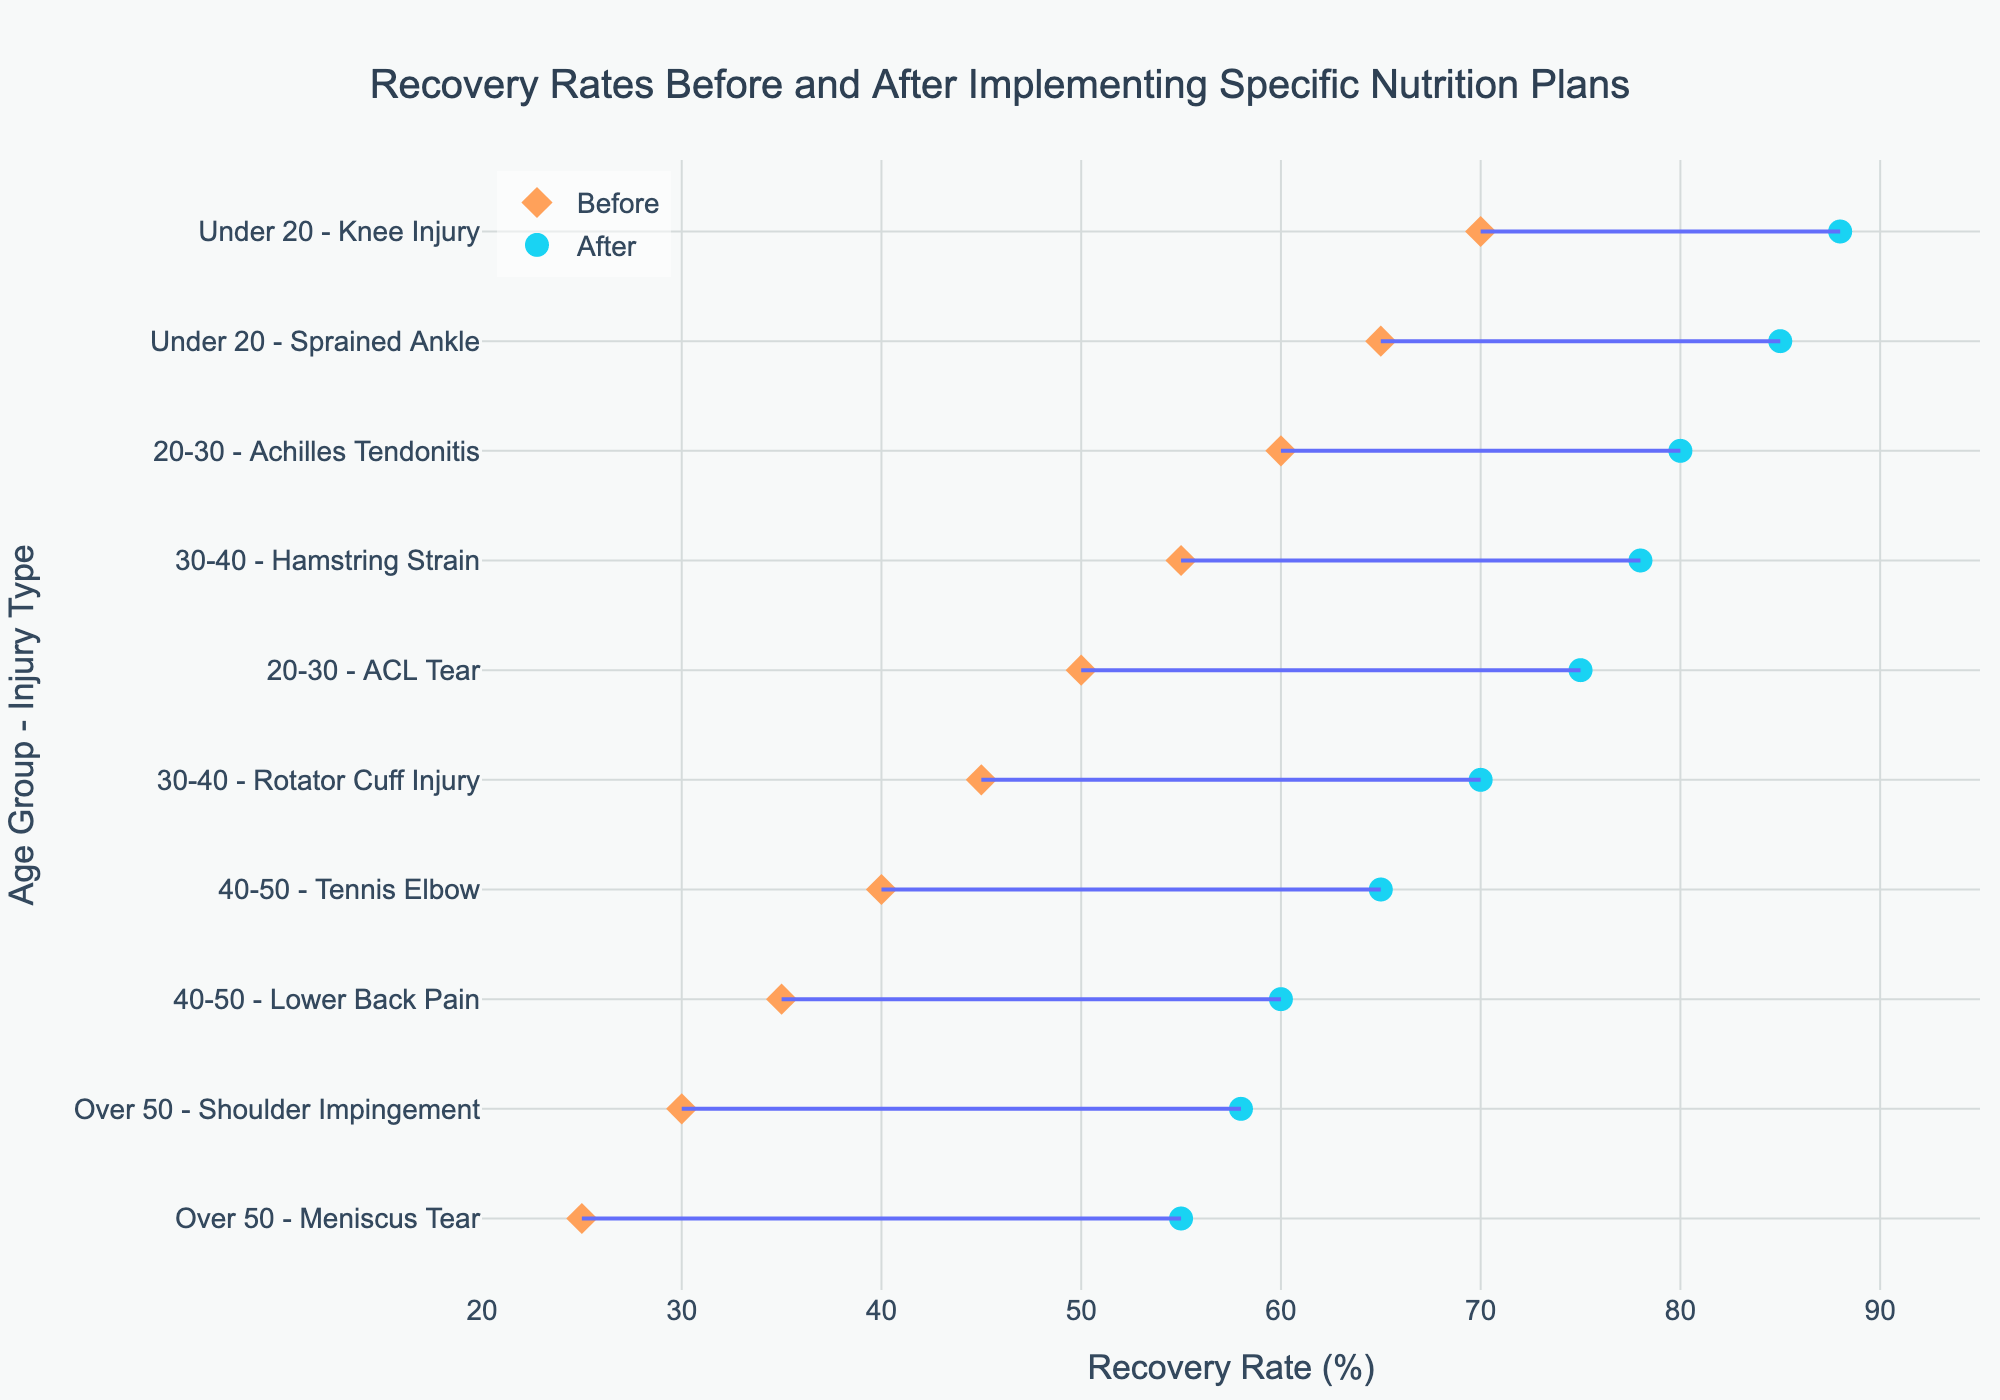What's the title of the plot? The title is typically located at the top of the plot. In this case, it states "Recovery Rates Before and After Implementing Specific Nutrition Plans".
Answer: Recovery Rates Before and After Implementing Specific Nutrition Plans What's the range of recovery rates on the x-axis? By examining the x-axis, we can see the minimum and maximum values provided. The range starts at 20 and goes up to 95.
Answer: 20 to 95 What colors are used to represent the recovery rates before and after implementing the specific nutrition plans? The colors of the markers indicate the two different states: the 'Before' rates are represented by an orange color and the 'After' rates by a light blue color.
Answer: Orange and Light Blue Which age group and injury type had the highest increase in recovery rate after implementing the nutrition plan? By comparing the lines, we can identify the largest vertical distance between the 'Before' and 'After' markers. The Under 20 age group with a Knee Injury shows an increase from 70% to 88%, a difference of 18%.
Answer: Under 20 - Knee Injury How many different nutrition plans are evaluated in the plot? By counting the distinct plans mentioned in the hovertext of the markers, we find there are five distinct nutrition plans (Omega-3 Enhanced Diet, High-Protein Diet, Antioxidant-Rich Diet, Anti-Inflammatory Diet, Calcium and Vitamin D-Rich Diet).
Answer: 5 For the age group Over 50, which injury type had the lowest recovery rate before implementing the nutrition plan? Looking at the pair of markers for the Over 50 age group, the injury with the lower 'Before' recovery rate is the Meniscus Tear at 25%.
Answer: Meniscus Tear (25%) What was the recovery rate after implementing the nutrition plan for the age group 20-30 with an ACL Tear? Identify the specific injury and age group and check the blue marker for its value, which is 75%.
Answer: 75% What can be inferred about the general trend in recovery rates after implementing the nutrition plans? Observe all the lines in the plot: they all have an upward slope from the orange to the blue marker, indicating an improvement in recovery rates after the plans.
Answer: Recovery rates generally improved What is the average recovery rate before implementing the nutrition plans for the injuries listed? To find the average, sum all the 'Recovery Rate Before' values (65+70+60+50+55+45+40+35+30+25 = 475) and divide by the number of injuries, which is 10. Therefore, the average is 475/10 = 47.5.
Answer: 47.5 Which injury type in the 30-40 age group had a better recovery rate after the nutrition plan implementation? Comparing within the 30-40 age group between Hamstring Strain and Rotator Cuff Injury, the recovery rates are 78% and 70%, respectively. Thus, Hamstring Strain had a better recovery rate.
Answer: Hamstring Strain (78%) 